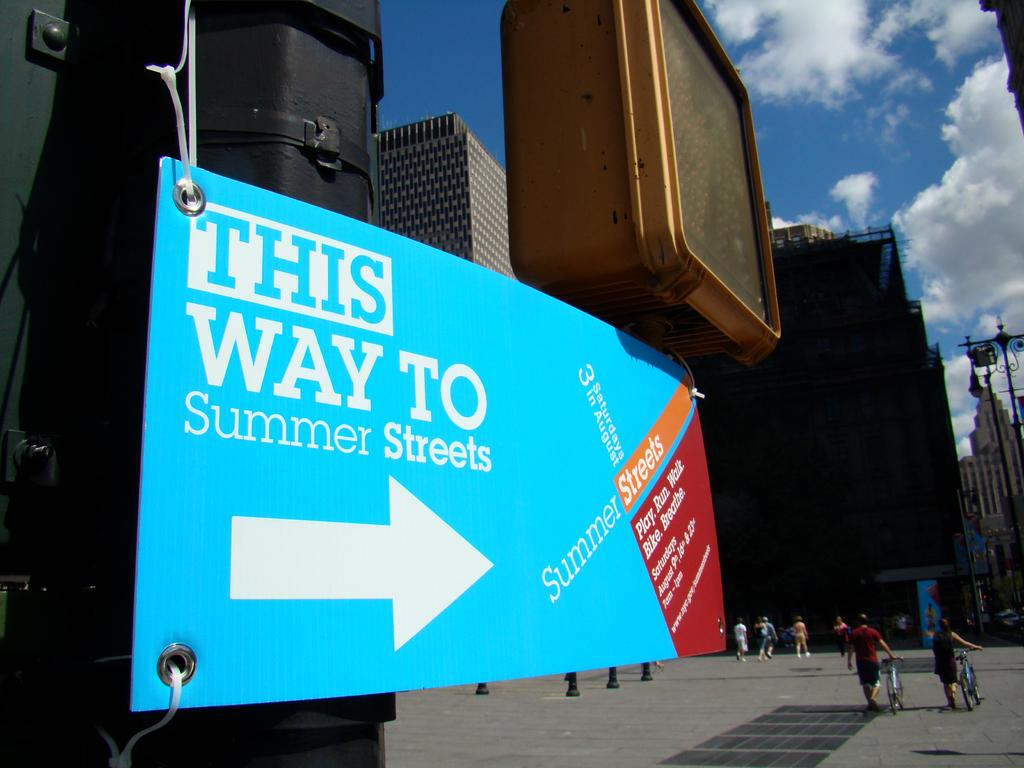<image>
Give a short and clear explanation of the subsequent image. The large bright blue signs indicates which way to go to get to Summer Streets. 